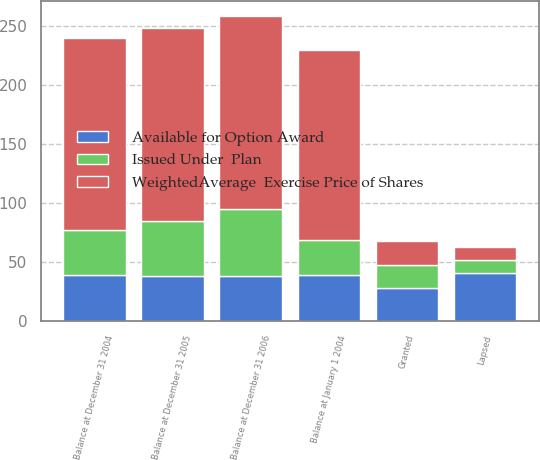Convert chart to OTSL. <chart><loc_0><loc_0><loc_500><loc_500><stacked_bar_chart><ecel><fcel>Balance at January 1 2004<fcel>Granted<fcel>Lapsed<fcel>Balance at December 31 2004<fcel>Balance at December 31 2005<fcel>Balance at December 31 2006<nl><fcel>Issued Under  Plan<fcel>29<fcel>20<fcel>11<fcel>38<fcel>46<fcel>57<nl><fcel>WeightedAverage  Exercise Price of Shares<fcel>161<fcel>20<fcel>11<fcel>163<fcel>164<fcel>163<nl><fcel>Available for Option Award<fcel>39.24<fcel>27.88<fcel>40.69<fcel>38.87<fcel>38.45<fcel>38.16<nl></chart> 